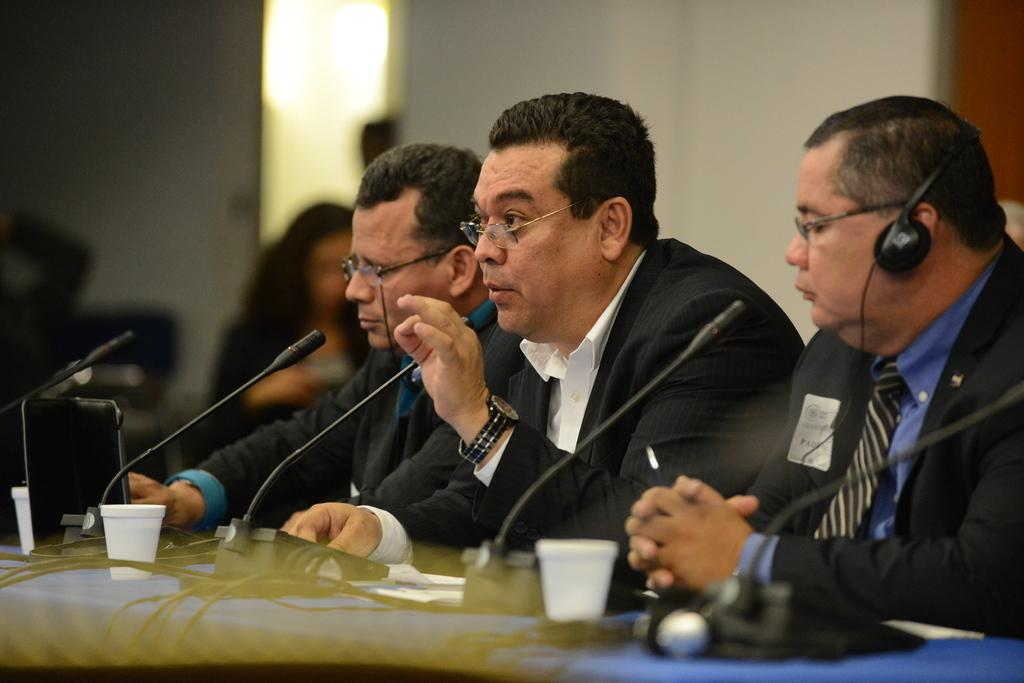How many people are in the image? There are people in the image, but the exact number is not specified. What is in front of the people? There is a table in front of the people. What can be found on the table? There are microphones (mics), cups, and other objects on the table. What is visible in the background of the image? There is a wall in the background of the image. What type of quicksand can be seen in the image? There is no quicksand present in the image. How many achievers are visible in the image? The term "achiever" is not mentioned in the facts, so it is not possible to determine the number of achievers in the image. 